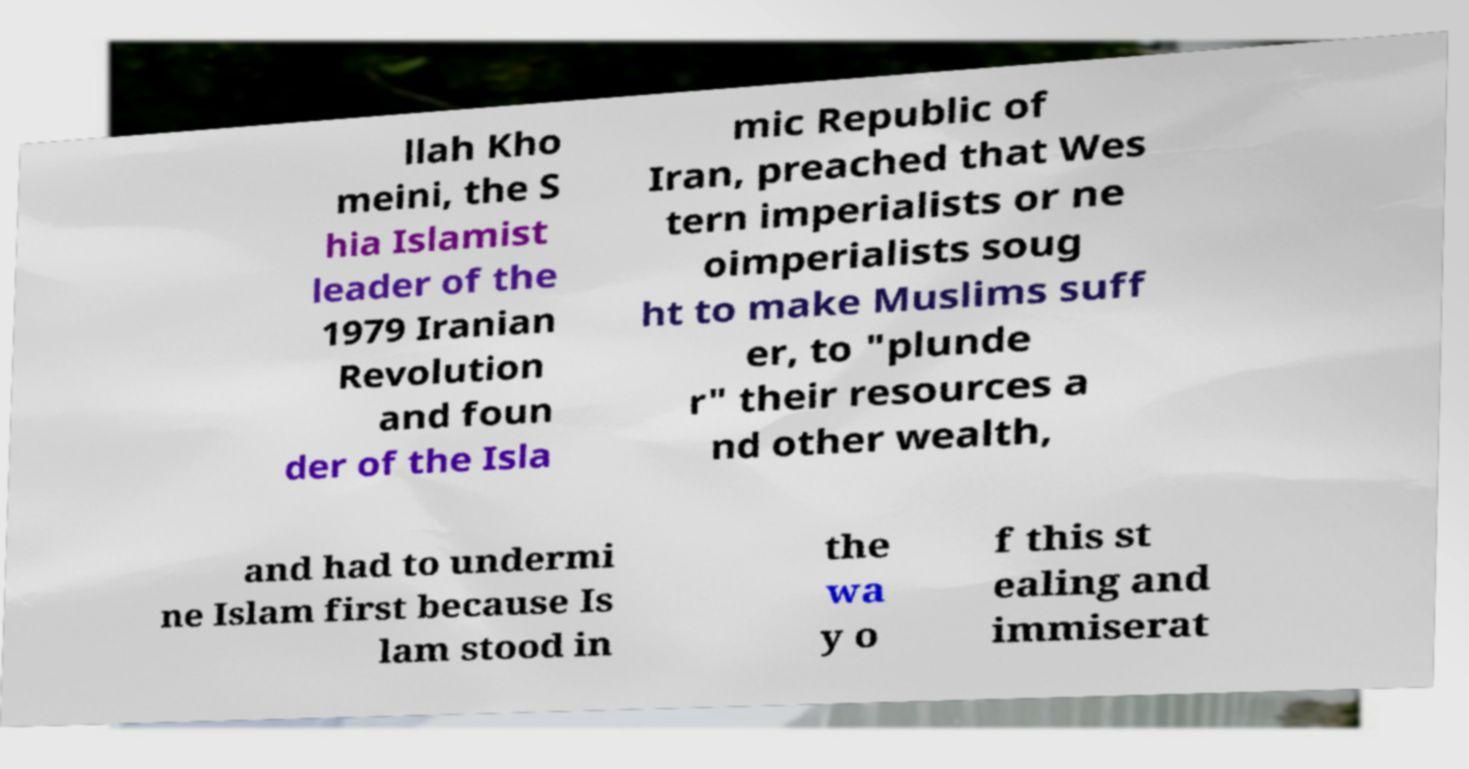Could you extract and type out the text from this image? llah Kho meini, the S hia Islamist leader of the 1979 Iranian Revolution and foun der of the Isla mic Republic of Iran, preached that Wes tern imperialists or ne oimperialists soug ht to make Muslims suff er, to "plunde r" their resources a nd other wealth, and had to undermi ne Islam first because Is lam stood in the wa y o f this st ealing and immiserat 